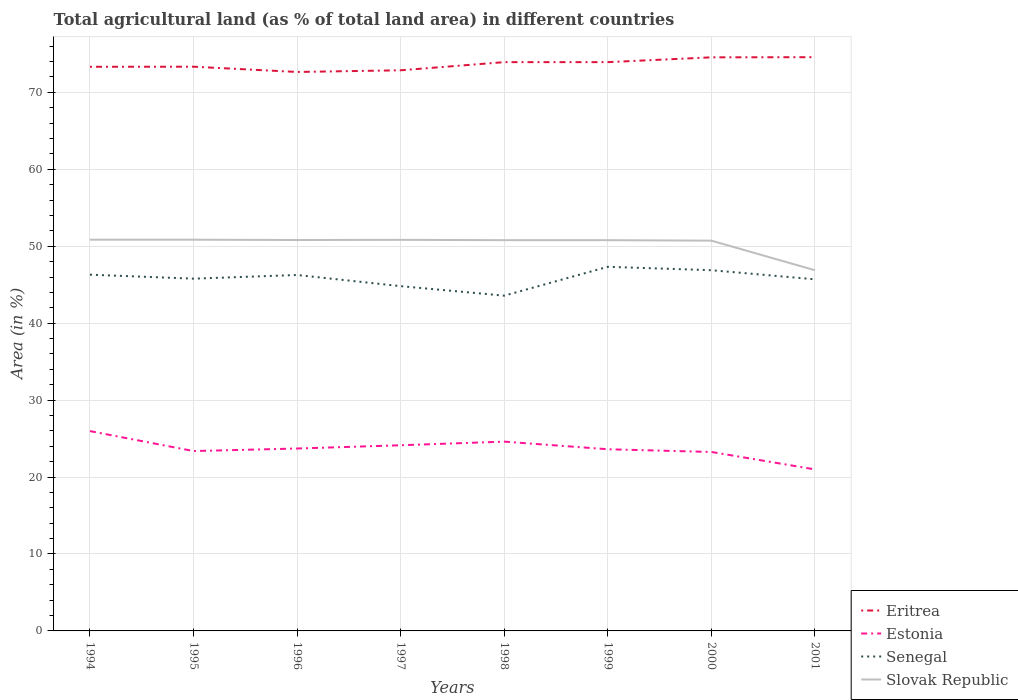How many different coloured lines are there?
Provide a short and direct response. 4. Does the line corresponding to Slovak Republic intersect with the line corresponding to Eritrea?
Keep it short and to the point. No. Across all years, what is the maximum percentage of agricultural land in Estonia?
Your response must be concise. 21. In which year was the percentage of agricultural land in Estonia maximum?
Offer a terse response. 2001. What is the total percentage of agricultural land in Eritrea in the graph?
Your response must be concise. -0.62. What is the difference between the highest and the second highest percentage of agricultural land in Senegal?
Keep it short and to the point. 3.75. Is the percentage of agricultural land in Eritrea strictly greater than the percentage of agricultural land in Senegal over the years?
Keep it short and to the point. No. How many lines are there?
Your answer should be compact. 4. How many years are there in the graph?
Provide a succinct answer. 8. Does the graph contain any zero values?
Provide a succinct answer. No. Does the graph contain grids?
Offer a terse response. Yes. Where does the legend appear in the graph?
Keep it short and to the point. Bottom right. How are the legend labels stacked?
Your response must be concise. Vertical. What is the title of the graph?
Ensure brevity in your answer.  Total agricultural land (as % of total land area) in different countries. What is the label or title of the X-axis?
Your answer should be very brief. Years. What is the label or title of the Y-axis?
Provide a short and direct response. Area (in %). What is the Area (in %) in Eritrea in 1994?
Keep it short and to the point. 73.33. What is the Area (in %) in Estonia in 1994?
Provide a succinct answer. 25.97. What is the Area (in %) of Senegal in 1994?
Offer a terse response. 46.3. What is the Area (in %) in Slovak Republic in 1994?
Provide a short and direct response. 50.85. What is the Area (in %) of Eritrea in 1995?
Keep it short and to the point. 73.34. What is the Area (in %) in Estonia in 1995?
Ensure brevity in your answer.  23.38. What is the Area (in %) in Senegal in 1995?
Offer a very short reply. 45.79. What is the Area (in %) of Slovak Republic in 1995?
Your answer should be compact. 50.85. What is the Area (in %) of Eritrea in 1996?
Ensure brevity in your answer.  72.65. What is the Area (in %) of Estonia in 1996?
Make the answer very short. 23.71. What is the Area (in %) in Senegal in 1996?
Your response must be concise. 46.26. What is the Area (in %) of Slovak Republic in 1996?
Provide a succinct answer. 50.81. What is the Area (in %) of Eritrea in 1997?
Make the answer very short. 72.87. What is the Area (in %) in Estonia in 1997?
Ensure brevity in your answer.  24.13. What is the Area (in %) of Senegal in 1997?
Offer a terse response. 44.81. What is the Area (in %) in Slovak Republic in 1997?
Your answer should be compact. 50.83. What is the Area (in %) of Eritrea in 1998?
Provide a succinct answer. 73.93. What is the Area (in %) of Estonia in 1998?
Your response must be concise. 24.6. What is the Area (in %) of Senegal in 1998?
Offer a terse response. 43.58. What is the Area (in %) in Slovak Republic in 1998?
Provide a short and direct response. 50.79. What is the Area (in %) in Eritrea in 1999?
Offer a very short reply. 73.93. What is the Area (in %) in Estonia in 1999?
Provide a succinct answer. 23.61. What is the Area (in %) of Senegal in 1999?
Provide a short and direct response. 47.33. What is the Area (in %) in Slovak Republic in 1999?
Offer a very short reply. 50.79. What is the Area (in %) of Eritrea in 2000?
Your answer should be very brief. 74.55. What is the Area (in %) in Estonia in 2000?
Your answer should be compact. 23.26. What is the Area (in %) of Senegal in 2000?
Give a very brief answer. 46.89. What is the Area (in %) in Slovak Republic in 2000?
Your response must be concise. 50.73. What is the Area (in %) in Eritrea in 2001?
Your answer should be compact. 74.57. What is the Area (in %) of Estonia in 2001?
Your response must be concise. 21. What is the Area (in %) of Senegal in 2001?
Your answer should be very brief. 45.7. What is the Area (in %) in Slovak Republic in 2001?
Offer a terse response. 46.88. Across all years, what is the maximum Area (in %) of Eritrea?
Offer a terse response. 74.57. Across all years, what is the maximum Area (in %) in Estonia?
Your response must be concise. 25.97. Across all years, what is the maximum Area (in %) of Senegal?
Make the answer very short. 47.33. Across all years, what is the maximum Area (in %) of Slovak Republic?
Offer a terse response. 50.85. Across all years, what is the minimum Area (in %) of Eritrea?
Your response must be concise. 72.65. Across all years, what is the minimum Area (in %) of Estonia?
Your answer should be compact. 21. Across all years, what is the minimum Area (in %) in Senegal?
Your answer should be compact. 43.58. Across all years, what is the minimum Area (in %) in Slovak Republic?
Provide a succinct answer. 46.88. What is the total Area (in %) in Eritrea in the graph?
Your response must be concise. 589.18. What is the total Area (in %) in Estonia in the graph?
Keep it short and to the point. 189.67. What is the total Area (in %) in Senegal in the graph?
Your response must be concise. 366.66. What is the total Area (in %) of Slovak Republic in the graph?
Offer a terse response. 402.54. What is the difference between the Area (in %) of Eritrea in 1994 and that in 1995?
Provide a short and direct response. -0.01. What is the difference between the Area (in %) in Estonia in 1994 and that in 1995?
Provide a short and direct response. 2.6. What is the difference between the Area (in %) of Senegal in 1994 and that in 1995?
Make the answer very short. 0.52. What is the difference between the Area (in %) in Eritrea in 1994 and that in 1996?
Provide a succinct answer. 0.67. What is the difference between the Area (in %) in Estonia in 1994 and that in 1996?
Your response must be concise. 2.26. What is the difference between the Area (in %) in Senegal in 1994 and that in 1996?
Offer a very short reply. 0.04. What is the difference between the Area (in %) in Slovak Republic in 1994 and that in 1996?
Make the answer very short. 0.04. What is the difference between the Area (in %) of Eritrea in 1994 and that in 1997?
Make the answer very short. 0.46. What is the difference between the Area (in %) in Estonia in 1994 and that in 1997?
Keep it short and to the point. 1.84. What is the difference between the Area (in %) of Senegal in 1994 and that in 1997?
Make the answer very short. 1.49. What is the difference between the Area (in %) in Slovak Republic in 1994 and that in 1997?
Ensure brevity in your answer.  0.02. What is the difference between the Area (in %) of Eritrea in 1994 and that in 1998?
Ensure brevity in your answer.  -0.6. What is the difference between the Area (in %) of Estonia in 1994 and that in 1998?
Provide a succinct answer. 1.37. What is the difference between the Area (in %) in Senegal in 1994 and that in 1998?
Make the answer very short. 2.73. What is the difference between the Area (in %) in Slovak Republic in 1994 and that in 1998?
Your answer should be compact. 0.06. What is the difference between the Area (in %) in Eritrea in 1994 and that in 1999?
Your answer should be compact. -0.6. What is the difference between the Area (in %) in Estonia in 1994 and that in 1999?
Your answer should be very brief. 2.36. What is the difference between the Area (in %) in Senegal in 1994 and that in 1999?
Your answer should be very brief. -1.02. What is the difference between the Area (in %) in Slovak Republic in 1994 and that in 1999?
Your answer should be very brief. 0.06. What is the difference between the Area (in %) in Eritrea in 1994 and that in 2000?
Give a very brief answer. -1.23. What is the difference between the Area (in %) in Estonia in 1994 and that in 2000?
Your answer should be compact. 2.71. What is the difference between the Area (in %) in Senegal in 1994 and that in 2000?
Make the answer very short. -0.58. What is the difference between the Area (in %) in Slovak Republic in 1994 and that in 2000?
Your answer should be very brief. 0.12. What is the difference between the Area (in %) of Eritrea in 1994 and that in 2001?
Provide a succinct answer. -1.25. What is the difference between the Area (in %) in Estonia in 1994 and that in 2001?
Offer a terse response. 4.98. What is the difference between the Area (in %) of Senegal in 1994 and that in 2001?
Your answer should be compact. 0.6. What is the difference between the Area (in %) of Slovak Republic in 1994 and that in 2001?
Provide a short and direct response. 3.97. What is the difference between the Area (in %) in Eritrea in 1995 and that in 1996?
Make the answer very short. 0.68. What is the difference between the Area (in %) in Estonia in 1995 and that in 1996?
Ensure brevity in your answer.  -0.33. What is the difference between the Area (in %) of Senegal in 1995 and that in 1996?
Provide a succinct answer. -0.48. What is the difference between the Area (in %) in Slovak Republic in 1995 and that in 1996?
Provide a succinct answer. 0.04. What is the difference between the Area (in %) of Eritrea in 1995 and that in 1997?
Your answer should be compact. 0.47. What is the difference between the Area (in %) of Estonia in 1995 and that in 1997?
Offer a terse response. -0.75. What is the difference between the Area (in %) in Senegal in 1995 and that in 1997?
Your answer should be very brief. 0.97. What is the difference between the Area (in %) of Slovak Republic in 1995 and that in 1997?
Your answer should be very brief. 0.02. What is the difference between the Area (in %) of Eritrea in 1995 and that in 1998?
Make the answer very short. -0.59. What is the difference between the Area (in %) in Estonia in 1995 and that in 1998?
Offer a very short reply. -1.23. What is the difference between the Area (in %) of Senegal in 1995 and that in 1998?
Your response must be concise. 2.21. What is the difference between the Area (in %) in Slovak Republic in 1995 and that in 1998?
Your answer should be compact. 0.06. What is the difference between the Area (in %) of Eritrea in 1995 and that in 1999?
Provide a short and direct response. -0.59. What is the difference between the Area (in %) in Estonia in 1995 and that in 1999?
Give a very brief answer. -0.24. What is the difference between the Area (in %) of Senegal in 1995 and that in 1999?
Offer a terse response. -1.54. What is the difference between the Area (in %) of Slovak Republic in 1995 and that in 1999?
Make the answer very short. 0.06. What is the difference between the Area (in %) of Eritrea in 1995 and that in 2000?
Your response must be concise. -1.22. What is the difference between the Area (in %) in Estonia in 1995 and that in 2000?
Your answer should be very brief. 0.12. What is the difference between the Area (in %) in Senegal in 1995 and that in 2000?
Your answer should be very brief. -1.1. What is the difference between the Area (in %) of Slovak Republic in 1995 and that in 2000?
Ensure brevity in your answer.  0.12. What is the difference between the Area (in %) in Eritrea in 1995 and that in 2001?
Offer a terse response. -1.24. What is the difference between the Area (in %) of Estonia in 1995 and that in 2001?
Your response must be concise. 2.38. What is the difference between the Area (in %) in Senegal in 1995 and that in 2001?
Your answer should be very brief. 0.08. What is the difference between the Area (in %) in Slovak Republic in 1995 and that in 2001?
Give a very brief answer. 3.97. What is the difference between the Area (in %) of Eritrea in 1996 and that in 1997?
Offer a very short reply. -0.22. What is the difference between the Area (in %) of Estonia in 1996 and that in 1997?
Provide a short and direct response. -0.42. What is the difference between the Area (in %) of Senegal in 1996 and that in 1997?
Keep it short and to the point. 1.45. What is the difference between the Area (in %) of Slovak Republic in 1996 and that in 1997?
Provide a succinct answer. -0.02. What is the difference between the Area (in %) in Eritrea in 1996 and that in 1998?
Give a very brief answer. -1.28. What is the difference between the Area (in %) in Estonia in 1996 and that in 1998?
Offer a terse response. -0.9. What is the difference between the Area (in %) of Senegal in 1996 and that in 1998?
Ensure brevity in your answer.  2.69. What is the difference between the Area (in %) in Slovak Republic in 1996 and that in 1998?
Ensure brevity in your answer.  0.02. What is the difference between the Area (in %) of Eritrea in 1996 and that in 1999?
Your answer should be compact. -1.28. What is the difference between the Area (in %) of Estonia in 1996 and that in 1999?
Provide a succinct answer. 0.09. What is the difference between the Area (in %) of Senegal in 1996 and that in 1999?
Keep it short and to the point. -1.06. What is the difference between the Area (in %) of Slovak Republic in 1996 and that in 1999?
Your response must be concise. 0.02. What is the difference between the Area (in %) in Eritrea in 1996 and that in 2000?
Your answer should be very brief. -1.9. What is the difference between the Area (in %) of Estonia in 1996 and that in 2000?
Give a very brief answer. 0.45. What is the difference between the Area (in %) of Senegal in 1996 and that in 2000?
Provide a succinct answer. -0.62. What is the difference between the Area (in %) in Slovak Republic in 1996 and that in 2000?
Your response must be concise. 0.08. What is the difference between the Area (in %) of Eritrea in 1996 and that in 2001?
Provide a short and direct response. -1.92. What is the difference between the Area (in %) of Estonia in 1996 and that in 2001?
Your answer should be compact. 2.71. What is the difference between the Area (in %) in Senegal in 1996 and that in 2001?
Offer a very short reply. 0.56. What is the difference between the Area (in %) of Slovak Republic in 1996 and that in 2001?
Your answer should be compact. 3.93. What is the difference between the Area (in %) in Eritrea in 1997 and that in 1998?
Ensure brevity in your answer.  -1.06. What is the difference between the Area (in %) of Estonia in 1997 and that in 1998?
Ensure brevity in your answer.  -0.47. What is the difference between the Area (in %) in Senegal in 1997 and that in 1998?
Your response must be concise. 1.24. What is the difference between the Area (in %) of Slovak Republic in 1997 and that in 1998?
Ensure brevity in your answer.  0.04. What is the difference between the Area (in %) in Eritrea in 1997 and that in 1999?
Your answer should be very brief. -1.06. What is the difference between the Area (in %) of Estonia in 1997 and that in 1999?
Provide a succinct answer. 0.52. What is the difference between the Area (in %) in Senegal in 1997 and that in 1999?
Keep it short and to the point. -2.51. What is the difference between the Area (in %) in Slovak Republic in 1997 and that in 1999?
Offer a very short reply. 0.04. What is the difference between the Area (in %) in Eritrea in 1997 and that in 2000?
Offer a terse response. -1.68. What is the difference between the Area (in %) in Estonia in 1997 and that in 2000?
Give a very brief answer. 0.87. What is the difference between the Area (in %) of Senegal in 1997 and that in 2000?
Your response must be concise. -2.07. What is the difference between the Area (in %) of Slovak Republic in 1997 and that in 2000?
Your response must be concise. 0.1. What is the difference between the Area (in %) in Eritrea in 1997 and that in 2001?
Your response must be concise. -1.7. What is the difference between the Area (in %) in Estonia in 1997 and that in 2001?
Give a very brief answer. 3.14. What is the difference between the Area (in %) in Senegal in 1997 and that in 2001?
Make the answer very short. -0.89. What is the difference between the Area (in %) in Slovak Republic in 1997 and that in 2001?
Make the answer very short. 3.95. What is the difference between the Area (in %) of Senegal in 1998 and that in 1999?
Your answer should be very brief. -3.75. What is the difference between the Area (in %) of Eritrea in 1998 and that in 2000?
Give a very brief answer. -0.62. What is the difference between the Area (in %) of Estonia in 1998 and that in 2000?
Keep it short and to the point. 1.34. What is the difference between the Area (in %) of Senegal in 1998 and that in 2000?
Provide a short and direct response. -3.31. What is the difference between the Area (in %) of Slovak Republic in 1998 and that in 2000?
Give a very brief answer. 0.06. What is the difference between the Area (in %) in Eritrea in 1998 and that in 2001?
Offer a terse response. -0.64. What is the difference between the Area (in %) of Estonia in 1998 and that in 2001?
Keep it short and to the point. 3.61. What is the difference between the Area (in %) of Senegal in 1998 and that in 2001?
Your answer should be compact. -2.12. What is the difference between the Area (in %) of Slovak Republic in 1998 and that in 2001?
Your answer should be compact. 3.91. What is the difference between the Area (in %) of Eritrea in 1999 and that in 2000?
Keep it short and to the point. -0.62. What is the difference between the Area (in %) in Estonia in 1999 and that in 2000?
Provide a short and direct response. 0.35. What is the difference between the Area (in %) in Senegal in 1999 and that in 2000?
Your answer should be compact. 0.44. What is the difference between the Area (in %) in Slovak Republic in 1999 and that in 2000?
Keep it short and to the point. 0.06. What is the difference between the Area (in %) of Eritrea in 1999 and that in 2001?
Offer a very short reply. -0.64. What is the difference between the Area (in %) of Estonia in 1999 and that in 2001?
Your answer should be compact. 2.62. What is the difference between the Area (in %) in Senegal in 1999 and that in 2001?
Your answer should be very brief. 1.63. What is the difference between the Area (in %) of Slovak Republic in 1999 and that in 2001?
Provide a succinct answer. 3.91. What is the difference between the Area (in %) in Eritrea in 2000 and that in 2001?
Provide a succinct answer. -0.02. What is the difference between the Area (in %) of Estonia in 2000 and that in 2001?
Keep it short and to the point. 2.26. What is the difference between the Area (in %) of Senegal in 2000 and that in 2001?
Your answer should be compact. 1.18. What is the difference between the Area (in %) of Slovak Republic in 2000 and that in 2001?
Ensure brevity in your answer.  3.85. What is the difference between the Area (in %) in Eritrea in 1994 and the Area (in %) in Estonia in 1995?
Your answer should be very brief. 49.95. What is the difference between the Area (in %) in Eritrea in 1994 and the Area (in %) in Senegal in 1995?
Ensure brevity in your answer.  27.54. What is the difference between the Area (in %) in Eritrea in 1994 and the Area (in %) in Slovak Republic in 1995?
Offer a very short reply. 22.47. What is the difference between the Area (in %) in Estonia in 1994 and the Area (in %) in Senegal in 1995?
Your answer should be very brief. -19.81. What is the difference between the Area (in %) of Estonia in 1994 and the Area (in %) of Slovak Republic in 1995?
Offer a terse response. -24.88. What is the difference between the Area (in %) in Senegal in 1994 and the Area (in %) in Slovak Republic in 1995?
Make the answer very short. -4.55. What is the difference between the Area (in %) of Eritrea in 1994 and the Area (in %) of Estonia in 1996?
Make the answer very short. 49.62. What is the difference between the Area (in %) in Eritrea in 1994 and the Area (in %) in Senegal in 1996?
Provide a short and direct response. 27.06. What is the difference between the Area (in %) of Eritrea in 1994 and the Area (in %) of Slovak Republic in 1996?
Your response must be concise. 22.52. What is the difference between the Area (in %) of Estonia in 1994 and the Area (in %) of Senegal in 1996?
Ensure brevity in your answer.  -20.29. What is the difference between the Area (in %) of Estonia in 1994 and the Area (in %) of Slovak Republic in 1996?
Keep it short and to the point. -24.84. What is the difference between the Area (in %) of Senegal in 1994 and the Area (in %) of Slovak Republic in 1996?
Keep it short and to the point. -4.51. What is the difference between the Area (in %) of Eritrea in 1994 and the Area (in %) of Estonia in 1997?
Ensure brevity in your answer.  49.19. What is the difference between the Area (in %) in Eritrea in 1994 and the Area (in %) in Senegal in 1997?
Ensure brevity in your answer.  28.51. What is the difference between the Area (in %) in Eritrea in 1994 and the Area (in %) in Slovak Republic in 1997?
Keep it short and to the point. 22.5. What is the difference between the Area (in %) in Estonia in 1994 and the Area (in %) in Senegal in 1997?
Provide a short and direct response. -18.84. What is the difference between the Area (in %) in Estonia in 1994 and the Area (in %) in Slovak Republic in 1997?
Your response must be concise. -24.86. What is the difference between the Area (in %) of Senegal in 1994 and the Area (in %) of Slovak Republic in 1997?
Keep it short and to the point. -4.53. What is the difference between the Area (in %) in Eritrea in 1994 and the Area (in %) in Estonia in 1998?
Your answer should be very brief. 48.72. What is the difference between the Area (in %) in Eritrea in 1994 and the Area (in %) in Senegal in 1998?
Make the answer very short. 29.75. What is the difference between the Area (in %) of Eritrea in 1994 and the Area (in %) of Slovak Republic in 1998?
Provide a short and direct response. 22.54. What is the difference between the Area (in %) of Estonia in 1994 and the Area (in %) of Senegal in 1998?
Keep it short and to the point. -17.6. What is the difference between the Area (in %) in Estonia in 1994 and the Area (in %) in Slovak Republic in 1998?
Your answer should be very brief. -24.82. What is the difference between the Area (in %) of Senegal in 1994 and the Area (in %) of Slovak Republic in 1998?
Make the answer very short. -4.49. What is the difference between the Area (in %) in Eritrea in 1994 and the Area (in %) in Estonia in 1999?
Your answer should be very brief. 49.71. What is the difference between the Area (in %) of Eritrea in 1994 and the Area (in %) of Senegal in 1999?
Keep it short and to the point. 26. What is the difference between the Area (in %) in Eritrea in 1994 and the Area (in %) in Slovak Republic in 1999?
Provide a succinct answer. 22.54. What is the difference between the Area (in %) in Estonia in 1994 and the Area (in %) in Senegal in 1999?
Provide a short and direct response. -21.35. What is the difference between the Area (in %) of Estonia in 1994 and the Area (in %) of Slovak Republic in 1999?
Your answer should be compact. -24.82. What is the difference between the Area (in %) in Senegal in 1994 and the Area (in %) in Slovak Republic in 1999?
Provide a succinct answer. -4.49. What is the difference between the Area (in %) of Eritrea in 1994 and the Area (in %) of Estonia in 2000?
Keep it short and to the point. 50.07. What is the difference between the Area (in %) of Eritrea in 1994 and the Area (in %) of Senegal in 2000?
Make the answer very short. 26.44. What is the difference between the Area (in %) in Eritrea in 1994 and the Area (in %) in Slovak Republic in 2000?
Provide a succinct answer. 22.6. What is the difference between the Area (in %) of Estonia in 1994 and the Area (in %) of Senegal in 2000?
Keep it short and to the point. -20.91. What is the difference between the Area (in %) of Estonia in 1994 and the Area (in %) of Slovak Republic in 2000?
Provide a short and direct response. -24.75. What is the difference between the Area (in %) of Senegal in 1994 and the Area (in %) of Slovak Republic in 2000?
Offer a terse response. -4.42. What is the difference between the Area (in %) in Eritrea in 1994 and the Area (in %) in Estonia in 2001?
Your answer should be very brief. 52.33. What is the difference between the Area (in %) of Eritrea in 1994 and the Area (in %) of Senegal in 2001?
Provide a succinct answer. 27.62. What is the difference between the Area (in %) of Eritrea in 1994 and the Area (in %) of Slovak Republic in 2001?
Provide a short and direct response. 26.45. What is the difference between the Area (in %) of Estonia in 1994 and the Area (in %) of Senegal in 2001?
Offer a very short reply. -19.73. What is the difference between the Area (in %) in Estonia in 1994 and the Area (in %) in Slovak Republic in 2001?
Make the answer very short. -20.91. What is the difference between the Area (in %) in Senegal in 1994 and the Area (in %) in Slovak Republic in 2001?
Offer a terse response. -0.58. What is the difference between the Area (in %) of Eritrea in 1995 and the Area (in %) of Estonia in 1996?
Your answer should be very brief. 49.63. What is the difference between the Area (in %) of Eritrea in 1995 and the Area (in %) of Senegal in 1996?
Your response must be concise. 27.07. What is the difference between the Area (in %) in Eritrea in 1995 and the Area (in %) in Slovak Republic in 1996?
Your response must be concise. 22.53. What is the difference between the Area (in %) of Estonia in 1995 and the Area (in %) of Senegal in 1996?
Give a very brief answer. -22.88. What is the difference between the Area (in %) in Estonia in 1995 and the Area (in %) in Slovak Republic in 1996?
Offer a terse response. -27.43. What is the difference between the Area (in %) in Senegal in 1995 and the Area (in %) in Slovak Republic in 1996?
Offer a terse response. -5.03. What is the difference between the Area (in %) of Eritrea in 1995 and the Area (in %) of Estonia in 1997?
Give a very brief answer. 49.2. What is the difference between the Area (in %) in Eritrea in 1995 and the Area (in %) in Senegal in 1997?
Give a very brief answer. 28.52. What is the difference between the Area (in %) in Eritrea in 1995 and the Area (in %) in Slovak Republic in 1997?
Your answer should be compact. 22.5. What is the difference between the Area (in %) in Estonia in 1995 and the Area (in %) in Senegal in 1997?
Make the answer very short. -21.44. What is the difference between the Area (in %) of Estonia in 1995 and the Area (in %) of Slovak Republic in 1997?
Ensure brevity in your answer.  -27.45. What is the difference between the Area (in %) in Senegal in 1995 and the Area (in %) in Slovak Republic in 1997?
Provide a short and direct response. -5.05. What is the difference between the Area (in %) in Eritrea in 1995 and the Area (in %) in Estonia in 1998?
Make the answer very short. 48.73. What is the difference between the Area (in %) of Eritrea in 1995 and the Area (in %) of Senegal in 1998?
Give a very brief answer. 29.76. What is the difference between the Area (in %) of Eritrea in 1995 and the Area (in %) of Slovak Republic in 1998?
Offer a very short reply. 22.55. What is the difference between the Area (in %) in Estonia in 1995 and the Area (in %) in Senegal in 1998?
Provide a short and direct response. -20.2. What is the difference between the Area (in %) of Estonia in 1995 and the Area (in %) of Slovak Republic in 1998?
Provide a succinct answer. -27.41. What is the difference between the Area (in %) of Senegal in 1995 and the Area (in %) of Slovak Republic in 1998?
Your answer should be very brief. -5. What is the difference between the Area (in %) in Eritrea in 1995 and the Area (in %) in Estonia in 1999?
Make the answer very short. 49.72. What is the difference between the Area (in %) in Eritrea in 1995 and the Area (in %) in Senegal in 1999?
Offer a very short reply. 26.01. What is the difference between the Area (in %) in Eritrea in 1995 and the Area (in %) in Slovak Republic in 1999?
Give a very brief answer. 22.55. What is the difference between the Area (in %) in Estonia in 1995 and the Area (in %) in Senegal in 1999?
Offer a very short reply. -23.95. What is the difference between the Area (in %) of Estonia in 1995 and the Area (in %) of Slovak Republic in 1999?
Your answer should be very brief. -27.41. What is the difference between the Area (in %) of Senegal in 1995 and the Area (in %) of Slovak Republic in 1999?
Offer a terse response. -5. What is the difference between the Area (in %) in Eritrea in 1995 and the Area (in %) in Estonia in 2000?
Your answer should be compact. 50.08. What is the difference between the Area (in %) of Eritrea in 1995 and the Area (in %) of Senegal in 2000?
Your answer should be very brief. 26.45. What is the difference between the Area (in %) of Eritrea in 1995 and the Area (in %) of Slovak Republic in 2000?
Your answer should be compact. 22.61. What is the difference between the Area (in %) of Estonia in 1995 and the Area (in %) of Senegal in 2000?
Offer a terse response. -23.51. What is the difference between the Area (in %) in Estonia in 1995 and the Area (in %) in Slovak Republic in 2000?
Provide a succinct answer. -27.35. What is the difference between the Area (in %) in Senegal in 1995 and the Area (in %) in Slovak Republic in 2000?
Give a very brief answer. -4.94. What is the difference between the Area (in %) of Eritrea in 1995 and the Area (in %) of Estonia in 2001?
Offer a terse response. 52.34. What is the difference between the Area (in %) of Eritrea in 1995 and the Area (in %) of Senegal in 2001?
Make the answer very short. 27.63. What is the difference between the Area (in %) in Eritrea in 1995 and the Area (in %) in Slovak Republic in 2001?
Give a very brief answer. 26.46. What is the difference between the Area (in %) in Estonia in 1995 and the Area (in %) in Senegal in 2001?
Offer a terse response. -22.32. What is the difference between the Area (in %) in Estonia in 1995 and the Area (in %) in Slovak Republic in 2001?
Ensure brevity in your answer.  -23.5. What is the difference between the Area (in %) in Senegal in 1995 and the Area (in %) in Slovak Republic in 2001?
Provide a succinct answer. -1.1. What is the difference between the Area (in %) of Eritrea in 1996 and the Area (in %) of Estonia in 1997?
Offer a terse response. 48.52. What is the difference between the Area (in %) of Eritrea in 1996 and the Area (in %) of Senegal in 1997?
Make the answer very short. 27.84. What is the difference between the Area (in %) of Eritrea in 1996 and the Area (in %) of Slovak Republic in 1997?
Give a very brief answer. 21.82. What is the difference between the Area (in %) of Estonia in 1996 and the Area (in %) of Senegal in 1997?
Offer a very short reply. -21.11. What is the difference between the Area (in %) in Estonia in 1996 and the Area (in %) in Slovak Republic in 1997?
Ensure brevity in your answer.  -27.12. What is the difference between the Area (in %) of Senegal in 1996 and the Area (in %) of Slovak Republic in 1997?
Keep it short and to the point. -4.57. What is the difference between the Area (in %) of Eritrea in 1996 and the Area (in %) of Estonia in 1998?
Keep it short and to the point. 48.05. What is the difference between the Area (in %) of Eritrea in 1996 and the Area (in %) of Senegal in 1998?
Your answer should be compact. 29.08. What is the difference between the Area (in %) in Eritrea in 1996 and the Area (in %) in Slovak Republic in 1998?
Ensure brevity in your answer.  21.86. What is the difference between the Area (in %) in Estonia in 1996 and the Area (in %) in Senegal in 1998?
Offer a terse response. -19.87. What is the difference between the Area (in %) in Estonia in 1996 and the Area (in %) in Slovak Republic in 1998?
Your response must be concise. -27.08. What is the difference between the Area (in %) in Senegal in 1996 and the Area (in %) in Slovak Republic in 1998?
Ensure brevity in your answer.  -4.53. What is the difference between the Area (in %) of Eritrea in 1996 and the Area (in %) of Estonia in 1999?
Your answer should be very brief. 49.04. What is the difference between the Area (in %) of Eritrea in 1996 and the Area (in %) of Senegal in 1999?
Offer a terse response. 25.33. What is the difference between the Area (in %) of Eritrea in 1996 and the Area (in %) of Slovak Republic in 1999?
Make the answer very short. 21.86. What is the difference between the Area (in %) in Estonia in 1996 and the Area (in %) in Senegal in 1999?
Give a very brief answer. -23.62. What is the difference between the Area (in %) in Estonia in 1996 and the Area (in %) in Slovak Republic in 1999?
Provide a succinct answer. -27.08. What is the difference between the Area (in %) in Senegal in 1996 and the Area (in %) in Slovak Republic in 1999?
Your response must be concise. -4.53. What is the difference between the Area (in %) in Eritrea in 1996 and the Area (in %) in Estonia in 2000?
Make the answer very short. 49.39. What is the difference between the Area (in %) of Eritrea in 1996 and the Area (in %) of Senegal in 2000?
Your response must be concise. 25.77. What is the difference between the Area (in %) of Eritrea in 1996 and the Area (in %) of Slovak Republic in 2000?
Your answer should be very brief. 21.93. What is the difference between the Area (in %) in Estonia in 1996 and the Area (in %) in Senegal in 2000?
Make the answer very short. -23.18. What is the difference between the Area (in %) in Estonia in 1996 and the Area (in %) in Slovak Republic in 2000?
Provide a succinct answer. -27.02. What is the difference between the Area (in %) in Senegal in 1996 and the Area (in %) in Slovak Republic in 2000?
Offer a terse response. -4.46. What is the difference between the Area (in %) in Eritrea in 1996 and the Area (in %) in Estonia in 2001?
Your response must be concise. 51.66. What is the difference between the Area (in %) in Eritrea in 1996 and the Area (in %) in Senegal in 2001?
Offer a terse response. 26.95. What is the difference between the Area (in %) of Eritrea in 1996 and the Area (in %) of Slovak Republic in 2001?
Offer a terse response. 25.77. What is the difference between the Area (in %) of Estonia in 1996 and the Area (in %) of Senegal in 2001?
Offer a very short reply. -21.99. What is the difference between the Area (in %) of Estonia in 1996 and the Area (in %) of Slovak Republic in 2001?
Ensure brevity in your answer.  -23.17. What is the difference between the Area (in %) in Senegal in 1996 and the Area (in %) in Slovak Republic in 2001?
Offer a terse response. -0.62. What is the difference between the Area (in %) of Eritrea in 1997 and the Area (in %) of Estonia in 1998?
Provide a short and direct response. 48.27. What is the difference between the Area (in %) in Eritrea in 1997 and the Area (in %) in Senegal in 1998?
Make the answer very short. 29.29. What is the difference between the Area (in %) of Eritrea in 1997 and the Area (in %) of Slovak Republic in 1998?
Give a very brief answer. 22.08. What is the difference between the Area (in %) in Estonia in 1997 and the Area (in %) in Senegal in 1998?
Give a very brief answer. -19.44. What is the difference between the Area (in %) in Estonia in 1997 and the Area (in %) in Slovak Republic in 1998?
Ensure brevity in your answer.  -26.66. What is the difference between the Area (in %) in Senegal in 1997 and the Area (in %) in Slovak Republic in 1998?
Provide a short and direct response. -5.98. What is the difference between the Area (in %) of Eritrea in 1997 and the Area (in %) of Estonia in 1999?
Provide a succinct answer. 49.26. What is the difference between the Area (in %) in Eritrea in 1997 and the Area (in %) in Senegal in 1999?
Make the answer very short. 25.54. What is the difference between the Area (in %) of Eritrea in 1997 and the Area (in %) of Slovak Republic in 1999?
Make the answer very short. 22.08. What is the difference between the Area (in %) of Estonia in 1997 and the Area (in %) of Senegal in 1999?
Offer a very short reply. -23.19. What is the difference between the Area (in %) of Estonia in 1997 and the Area (in %) of Slovak Republic in 1999?
Keep it short and to the point. -26.66. What is the difference between the Area (in %) in Senegal in 1997 and the Area (in %) in Slovak Republic in 1999?
Provide a short and direct response. -5.98. What is the difference between the Area (in %) of Eritrea in 1997 and the Area (in %) of Estonia in 2000?
Your answer should be compact. 49.61. What is the difference between the Area (in %) in Eritrea in 1997 and the Area (in %) in Senegal in 2000?
Provide a succinct answer. 25.99. What is the difference between the Area (in %) of Eritrea in 1997 and the Area (in %) of Slovak Republic in 2000?
Offer a terse response. 22.14. What is the difference between the Area (in %) of Estonia in 1997 and the Area (in %) of Senegal in 2000?
Your response must be concise. -22.75. What is the difference between the Area (in %) in Estonia in 1997 and the Area (in %) in Slovak Republic in 2000?
Give a very brief answer. -26.59. What is the difference between the Area (in %) of Senegal in 1997 and the Area (in %) of Slovak Republic in 2000?
Give a very brief answer. -5.91. What is the difference between the Area (in %) in Eritrea in 1997 and the Area (in %) in Estonia in 2001?
Ensure brevity in your answer.  51.88. What is the difference between the Area (in %) of Eritrea in 1997 and the Area (in %) of Senegal in 2001?
Your response must be concise. 27.17. What is the difference between the Area (in %) in Eritrea in 1997 and the Area (in %) in Slovak Republic in 2001?
Offer a very short reply. 25.99. What is the difference between the Area (in %) in Estonia in 1997 and the Area (in %) in Senegal in 2001?
Your answer should be compact. -21.57. What is the difference between the Area (in %) of Estonia in 1997 and the Area (in %) of Slovak Republic in 2001?
Provide a succinct answer. -22.75. What is the difference between the Area (in %) in Senegal in 1997 and the Area (in %) in Slovak Republic in 2001?
Keep it short and to the point. -2.07. What is the difference between the Area (in %) of Eritrea in 1998 and the Area (in %) of Estonia in 1999?
Your answer should be very brief. 50.32. What is the difference between the Area (in %) of Eritrea in 1998 and the Area (in %) of Senegal in 1999?
Offer a terse response. 26.6. What is the difference between the Area (in %) of Eritrea in 1998 and the Area (in %) of Slovak Republic in 1999?
Give a very brief answer. 23.14. What is the difference between the Area (in %) of Estonia in 1998 and the Area (in %) of Senegal in 1999?
Keep it short and to the point. -22.72. What is the difference between the Area (in %) in Estonia in 1998 and the Area (in %) in Slovak Republic in 1999?
Ensure brevity in your answer.  -26.19. What is the difference between the Area (in %) in Senegal in 1998 and the Area (in %) in Slovak Republic in 1999?
Offer a terse response. -7.21. What is the difference between the Area (in %) of Eritrea in 1998 and the Area (in %) of Estonia in 2000?
Ensure brevity in your answer.  50.67. What is the difference between the Area (in %) of Eritrea in 1998 and the Area (in %) of Senegal in 2000?
Ensure brevity in your answer.  27.04. What is the difference between the Area (in %) of Eritrea in 1998 and the Area (in %) of Slovak Republic in 2000?
Your answer should be very brief. 23.2. What is the difference between the Area (in %) in Estonia in 1998 and the Area (in %) in Senegal in 2000?
Ensure brevity in your answer.  -22.28. What is the difference between the Area (in %) of Estonia in 1998 and the Area (in %) of Slovak Republic in 2000?
Ensure brevity in your answer.  -26.12. What is the difference between the Area (in %) of Senegal in 1998 and the Area (in %) of Slovak Republic in 2000?
Your response must be concise. -7.15. What is the difference between the Area (in %) of Eritrea in 1998 and the Area (in %) of Estonia in 2001?
Ensure brevity in your answer.  52.94. What is the difference between the Area (in %) of Eritrea in 1998 and the Area (in %) of Senegal in 2001?
Ensure brevity in your answer.  28.23. What is the difference between the Area (in %) in Eritrea in 1998 and the Area (in %) in Slovak Republic in 2001?
Give a very brief answer. 27.05. What is the difference between the Area (in %) in Estonia in 1998 and the Area (in %) in Senegal in 2001?
Give a very brief answer. -21.1. What is the difference between the Area (in %) in Estonia in 1998 and the Area (in %) in Slovak Republic in 2001?
Give a very brief answer. -22.28. What is the difference between the Area (in %) of Senegal in 1998 and the Area (in %) of Slovak Republic in 2001?
Your answer should be very brief. -3.3. What is the difference between the Area (in %) in Eritrea in 1999 and the Area (in %) in Estonia in 2000?
Provide a short and direct response. 50.67. What is the difference between the Area (in %) of Eritrea in 1999 and the Area (in %) of Senegal in 2000?
Make the answer very short. 27.04. What is the difference between the Area (in %) in Eritrea in 1999 and the Area (in %) in Slovak Republic in 2000?
Offer a very short reply. 23.2. What is the difference between the Area (in %) in Estonia in 1999 and the Area (in %) in Senegal in 2000?
Your answer should be very brief. -23.27. What is the difference between the Area (in %) of Estonia in 1999 and the Area (in %) of Slovak Republic in 2000?
Ensure brevity in your answer.  -27.11. What is the difference between the Area (in %) of Senegal in 1999 and the Area (in %) of Slovak Republic in 2000?
Provide a short and direct response. -3.4. What is the difference between the Area (in %) in Eritrea in 1999 and the Area (in %) in Estonia in 2001?
Ensure brevity in your answer.  52.94. What is the difference between the Area (in %) in Eritrea in 1999 and the Area (in %) in Senegal in 2001?
Your response must be concise. 28.23. What is the difference between the Area (in %) of Eritrea in 1999 and the Area (in %) of Slovak Republic in 2001?
Keep it short and to the point. 27.05. What is the difference between the Area (in %) in Estonia in 1999 and the Area (in %) in Senegal in 2001?
Your answer should be very brief. -22.09. What is the difference between the Area (in %) in Estonia in 1999 and the Area (in %) in Slovak Republic in 2001?
Ensure brevity in your answer.  -23.27. What is the difference between the Area (in %) of Senegal in 1999 and the Area (in %) of Slovak Republic in 2001?
Provide a short and direct response. 0.45. What is the difference between the Area (in %) of Eritrea in 2000 and the Area (in %) of Estonia in 2001?
Ensure brevity in your answer.  53.56. What is the difference between the Area (in %) in Eritrea in 2000 and the Area (in %) in Senegal in 2001?
Your response must be concise. 28.85. What is the difference between the Area (in %) of Eritrea in 2000 and the Area (in %) of Slovak Republic in 2001?
Ensure brevity in your answer.  27.67. What is the difference between the Area (in %) of Estonia in 2000 and the Area (in %) of Senegal in 2001?
Offer a terse response. -22.44. What is the difference between the Area (in %) of Estonia in 2000 and the Area (in %) of Slovak Republic in 2001?
Keep it short and to the point. -23.62. What is the difference between the Area (in %) of Senegal in 2000 and the Area (in %) of Slovak Republic in 2001?
Provide a succinct answer. 0. What is the average Area (in %) in Eritrea per year?
Offer a terse response. 73.65. What is the average Area (in %) of Estonia per year?
Your answer should be very brief. 23.71. What is the average Area (in %) in Senegal per year?
Your answer should be compact. 45.83. What is the average Area (in %) of Slovak Republic per year?
Ensure brevity in your answer.  50.32. In the year 1994, what is the difference between the Area (in %) of Eritrea and Area (in %) of Estonia?
Give a very brief answer. 47.35. In the year 1994, what is the difference between the Area (in %) of Eritrea and Area (in %) of Senegal?
Offer a very short reply. 27.02. In the year 1994, what is the difference between the Area (in %) in Eritrea and Area (in %) in Slovak Republic?
Make the answer very short. 22.47. In the year 1994, what is the difference between the Area (in %) in Estonia and Area (in %) in Senegal?
Your response must be concise. -20.33. In the year 1994, what is the difference between the Area (in %) in Estonia and Area (in %) in Slovak Republic?
Provide a short and direct response. -24.88. In the year 1994, what is the difference between the Area (in %) in Senegal and Area (in %) in Slovak Republic?
Make the answer very short. -4.55. In the year 1995, what is the difference between the Area (in %) in Eritrea and Area (in %) in Estonia?
Provide a short and direct response. 49.96. In the year 1995, what is the difference between the Area (in %) in Eritrea and Area (in %) in Senegal?
Ensure brevity in your answer.  27.55. In the year 1995, what is the difference between the Area (in %) of Eritrea and Area (in %) of Slovak Republic?
Your response must be concise. 22.48. In the year 1995, what is the difference between the Area (in %) in Estonia and Area (in %) in Senegal?
Offer a terse response. -22.41. In the year 1995, what is the difference between the Area (in %) of Estonia and Area (in %) of Slovak Republic?
Offer a terse response. -27.47. In the year 1995, what is the difference between the Area (in %) in Senegal and Area (in %) in Slovak Republic?
Give a very brief answer. -5.07. In the year 1996, what is the difference between the Area (in %) of Eritrea and Area (in %) of Estonia?
Your answer should be compact. 48.95. In the year 1996, what is the difference between the Area (in %) in Eritrea and Area (in %) in Senegal?
Your answer should be very brief. 26.39. In the year 1996, what is the difference between the Area (in %) of Eritrea and Area (in %) of Slovak Republic?
Ensure brevity in your answer.  21.84. In the year 1996, what is the difference between the Area (in %) in Estonia and Area (in %) in Senegal?
Your answer should be compact. -22.55. In the year 1996, what is the difference between the Area (in %) in Estonia and Area (in %) in Slovak Republic?
Your answer should be very brief. -27.1. In the year 1996, what is the difference between the Area (in %) of Senegal and Area (in %) of Slovak Republic?
Keep it short and to the point. -4.55. In the year 1997, what is the difference between the Area (in %) in Eritrea and Area (in %) in Estonia?
Keep it short and to the point. 48.74. In the year 1997, what is the difference between the Area (in %) of Eritrea and Area (in %) of Senegal?
Offer a terse response. 28.06. In the year 1997, what is the difference between the Area (in %) of Eritrea and Area (in %) of Slovak Republic?
Your answer should be very brief. 22.04. In the year 1997, what is the difference between the Area (in %) in Estonia and Area (in %) in Senegal?
Keep it short and to the point. -20.68. In the year 1997, what is the difference between the Area (in %) of Estonia and Area (in %) of Slovak Republic?
Make the answer very short. -26.7. In the year 1997, what is the difference between the Area (in %) in Senegal and Area (in %) in Slovak Republic?
Provide a succinct answer. -6.02. In the year 1998, what is the difference between the Area (in %) in Eritrea and Area (in %) in Estonia?
Provide a succinct answer. 49.33. In the year 1998, what is the difference between the Area (in %) of Eritrea and Area (in %) of Senegal?
Make the answer very short. 30.35. In the year 1998, what is the difference between the Area (in %) of Eritrea and Area (in %) of Slovak Republic?
Keep it short and to the point. 23.14. In the year 1998, what is the difference between the Area (in %) of Estonia and Area (in %) of Senegal?
Give a very brief answer. -18.97. In the year 1998, what is the difference between the Area (in %) of Estonia and Area (in %) of Slovak Republic?
Your answer should be compact. -26.19. In the year 1998, what is the difference between the Area (in %) in Senegal and Area (in %) in Slovak Republic?
Provide a succinct answer. -7.21. In the year 1999, what is the difference between the Area (in %) of Eritrea and Area (in %) of Estonia?
Give a very brief answer. 50.32. In the year 1999, what is the difference between the Area (in %) in Eritrea and Area (in %) in Senegal?
Ensure brevity in your answer.  26.6. In the year 1999, what is the difference between the Area (in %) in Eritrea and Area (in %) in Slovak Republic?
Offer a very short reply. 23.14. In the year 1999, what is the difference between the Area (in %) in Estonia and Area (in %) in Senegal?
Make the answer very short. -23.71. In the year 1999, what is the difference between the Area (in %) of Estonia and Area (in %) of Slovak Republic?
Ensure brevity in your answer.  -27.18. In the year 1999, what is the difference between the Area (in %) of Senegal and Area (in %) of Slovak Republic?
Make the answer very short. -3.46. In the year 2000, what is the difference between the Area (in %) of Eritrea and Area (in %) of Estonia?
Keep it short and to the point. 51.29. In the year 2000, what is the difference between the Area (in %) in Eritrea and Area (in %) in Senegal?
Ensure brevity in your answer.  27.67. In the year 2000, what is the difference between the Area (in %) in Eritrea and Area (in %) in Slovak Republic?
Keep it short and to the point. 23.83. In the year 2000, what is the difference between the Area (in %) in Estonia and Area (in %) in Senegal?
Keep it short and to the point. -23.63. In the year 2000, what is the difference between the Area (in %) of Estonia and Area (in %) of Slovak Republic?
Ensure brevity in your answer.  -27.47. In the year 2000, what is the difference between the Area (in %) in Senegal and Area (in %) in Slovak Republic?
Offer a terse response. -3.84. In the year 2001, what is the difference between the Area (in %) in Eritrea and Area (in %) in Estonia?
Give a very brief answer. 53.58. In the year 2001, what is the difference between the Area (in %) in Eritrea and Area (in %) in Senegal?
Keep it short and to the point. 28.87. In the year 2001, what is the difference between the Area (in %) of Eritrea and Area (in %) of Slovak Republic?
Keep it short and to the point. 27.69. In the year 2001, what is the difference between the Area (in %) of Estonia and Area (in %) of Senegal?
Make the answer very short. -24.71. In the year 2001, what is the difference between the Area (in %) of Estonia and Area (in %) of Slovak Republic?
Your response must be concise. -25.89. In the year 2001, what is the difference between the Area (in %) in Senegal and Area (in %) in Slovak Republic?
Your response must be concise. -1.18. What is the ratio of the Area (in %) of Estonia in 1994 to that in 1995?
Keep it short and to the point. 1.11. What is the ratio of the Area (in %) in Senegal in 1994 to that in 1995?
Offer a terse response. 1.01. What is the ratio of the Area (in %) of Slovak Republic in 1994 to that in 1995?
Offer a very short reply. 1. What is the ratio of the Area (in %) in Eritrea in 1994 to that in 1996?
Offer a terse response. 1.01. What is the ratio of the Area (in %) in Estonia in 1994 to that in 1996?
Your answer should be compact. 1.1. What is the ratio of the Area (in %) of Senegal in 1994 to that in 1996?
Offer a terse response. 1. What is the ratio of the Area (in %) of Slovak Republic in 1994 to that in 1996?
Make the answer very short. 1. What is the ratio of the Area (in %) of Estonia in 1994 to that in 1997?
Your answer should be very brief. 1.08. What is the ratio of the Area (in %) of Slovak Republic in 1994 to that in 1997?
Make the answer very short. 1. What is the ratio of the Area (in %) in Eritrea in 1994 to that in 1998?
Ensure brevity in your answer.  0.99. What is the ratio of the Area (in %) in Estonia in 1994 to that in 1998?
Your response must be concise. 1.06. What is the ratio of the Area (in %) of Senegal in 1994 to that in 1998?
Offer a very short reply. 1.06. What is the ratio of the Area (in %) of Slovak Republic in 1994 to that in 1998?
Offer a very short reply. 1. What is the ratio of the Area (in %) of Estonia in 1994 to that in 1999?
Your response must be concise. 1.1. What is the ratio of the Area (in %) of Senegal in 1994 to that in 1999?
Provide a short and direct response. 0.98. What is the ratio of the Area (in %) of Slovak Republic in 1994 to that in 1999?
Your answer should be compact. 1. What is the ratio of the Area (in %) of Eritrea in 1994 to that in 2000?
Your answer should be very brief. 0.98. What is the ratio of the Area (in %) in Estonia in 1994 to that in 2000?
Provide a succinct answer. 1.12. What is the ratio of the Area (in %) in Senegal in 1994 to that in 2000?
Offer a terse response. 0.99. What is the ratio of the Area (in %) in Eritrea in 1994 to that in 2001?
Make the answer very short. 0.98. What is the ratio of the Area (in %) of Estonia in 1994 to that in 2001?
Your response must be concise. 1.24. What is the ratio of the Area (in %) in Senegal in 1994 to that in 2001?
Provide a succinct answer. 1.01. What is the ratio of the Area (in %) of Slovak Republic in 1994 to that in 2001?
Your answer should be very brief. 1.08. What is the ratio of the Area (in %) in Eritrea in 1995 to that in 1996?
Give a very brief answer. 1.01. What is the ratio of the Area (in %) in Estonia in 1995 to that in 1996?
Provide a succinct answer. 0.99. What is the ratio of the Area (in %) in Senegal in 1995 to that in 1996?
Provide a short and direct response. 0.99. What is the ratio of the Area (in %) in Eritrea in 1995 to that in 1997?
Keep it short and to the point. 1.01. What is the ratio of the Area (in %) in Estonia in 1995 to that in 1997?
Keep it short and to the point. 0.97. What is the ratio of the Area (in %) in Senegal in 1995 to that in 1997?
Keep it short and to the point. 1.02. What is the ratio of the Area (in %) of Slovak Republic in 1995 to that in 1997?
Your response must be concise. 1. What is the ratio of the Area (in %) of Estonia in 1995 to that in 1998?
Offer a terse response. 0.95. What is the ratio of the Area (in %) of Senegal in 1995 to that in 1998?
Offer a very short reply. 1.05. What is the ratio of the Area (in %) of Slovak Republic in 1995 to that in 1998?
Your response must be concise. 1. What is the ratio of the Area (in %) in Estonia in 1995 to that in 1999?
Ensure brevity in your answer.  0.99. What is the ratio of the Area (in %) of Senegal in 1995 to that in 1999?
Make the answer very short. 0.97. What is the ratio of the Area (in %) of Slovak Republic in 1995 to that in 1999?
Ensure brevity in your answer.  1. What is the ratio of the Area (in %) of Eritrea in 1995 to that in 2000?
Give a very brief answer. 0.98. What is the ratio of the Area (in %) in Senegal in 1995 to that in 2000?
Your answer should be very brief. 0.98. What is the ratio of the Area (in %) of Eritrea in 1995 to that in 2001?
Offer a terse response. 0.98. What is the ratio of the Area (in %) of Estonia in 1995 to that in 2001?
Give a very brief answer. 1.11. What is the ratio of the Area (in %) of Slovak Republic in 1995 to that in 2001?
Your answer should be very brief. 1.08. What is the ratio of the Area (in %) of Eritrea in 1996 to that in 1997?
Provide a short and direct response. 1. What is the ratio of the Area (in %) in Estonia in 1996 to that in 1997?
Your answer should be very brief. 0.98. What is the ratio of the Area (in %) of Senegal in 1996 to that in 1997?
Offer a very short reply. 1.03. What is the ratio of the Area (in %) of Eritrea in 1996 to that in 1998?
Provide a short and direct response. 0.98. What is the ratio of the Area (in %) in Estonia in 1996 to that in 1998?
Your response must be concise. 0.96. What is the ratio of the Area (in %) in Senegal in 1996 to that in 1998?
Give a very brief answer. 1.06. What is the ratio of the Area (in %) in Eritrea in 1996 to that in 1999?
Ensure brevity in your answer.  0.98. What is the ratio of the Area (in %) in Estonia in 1996 to that in 1999?
Your answer should be compact. 1. What is the ratio of the Area (in %) of Senegal in 1996 to that in 1999?
Provide a short and direct response. 0.98. What is the ratio of the Area (in %) in Slovak Republic in 1996 to that in 1999?
Provide a short and direct response. 1. What is the ratio of the Area (in %) of Eritrea in 1996 to that in 2000?
Your answer should be compact. 0.97. What is the ratio of the Area (in %) in Estonia in 1996 to that in 2000?
Your answer should be very brief. 1.02. What is the ratio of the Area (in %) in Senegal in 1996 to that in 2000?
Your answer should be compact. 0.99. What is the ratio of the Area (in %) in Slovak Republic in 1996 to that in 2000?
Provide a short and direct response. 1. What is the ratio of the Area (in %) of Eritrea in 1996 to that in 2001?
Keep it short and to the point. 0.97. What is the ratio of the Area (in %) of Estonia in 1996 to that in 2001?
Your answer should be compact. 1.13. What is the ratio of the Area (in %) in Senegal in 1996 to that in 2001?
Give a very brief answer. 1.01. What is the ratio of the Area (in %) in Slovak Republic in 1996 to that in 2001?
Offer a terse response. 1.08. What is the ratio of the Area (in %) of Eritrea in 1997 to that in 1998?
Your answer should be compact. 0.99. What is the ratio of the Area (in %) in Estonia in 1997 to that in 1998?
Offer a terse response. 0.98. What is the ratio of the Area (in %) of Senegal in 1997 to that in 1998?
Your answer should be compact. 1.03. What is the ratio of the Area (in %) of Slovak Republic in 1997 to that in 1998?
Make the answer very short. 1. What is the ratio of the Area (in %) in Eritrea in 1997 to that in 1999?
Provide a succinct answer. 0.99. What is the ratio of the Area (in %) in Senegal in 1997 to that in 1999?
Your answer should be compact. 0.95. What is the ratio of the Area (in %) of Slovak Republic in 1997 to that in 1999?
Provide a succinct answer. 1. What is the ratio of the Area (in %) in Eritrea in 1997 to that in 2000?
Your answer should be very brief. 0.98. What is the ratio of the Area (in %) in Estonia in 1997 to that in 2000?
Offer a terse response. 1.04. What is the ratio of the Area (in %) of Senegal in 1997 to that in 2000?
Ensure brevity in your answer.  0.96. What is the ratio of the Area (in %) of Slovak Republic in 1997 to that in 2000?
Offer a very short reply. 1. What is the ratio of the Area (in %) of Eritrea in 1997 to that in 2001?
Provide a succinct answer. 0.98. What is the ratio of the Area (in %) of Estonia in 1997 to that in 2001?
Offer a terse response. 1.15. What is the ratio of the Area (in %) in Senegal in 1997 to that in 2001?
Give a very brief answer. 0.98. What is the ratio of the Area (in %) of Slovak Republic in 1997 to that in 2001?
Ensure brevity in your answer.  1.08. What is the ratio of the Area (in %) in Eritrea in 1998 to that in 1999?
Offer a very short reply. 1. What is the ratio of the Area (in %) in Estonia in 1998 to that in 1999?
Offer a very short reply. 1.04. What is the ratio of the Area (in %) in Senegal in 1998 to that in 1999?
Offer a very short reply. 0.92. What is the ratio of the Area (in %) of Slovak Republic in 1998 to that in 1999?
Provide a succinct answer. 1. What is the ratio of the Area (in %) in Eritrea in 1998 to that in 2000?
Your answer should be compact. 0.99. What is the ratio of the Area (in %) of Estonia in 1998 to that in 2000?
Your answer should be very brief. 1.06. What is the ratio of the Area (in %) of Senegal in 1998 to that in 2000?
Keep it short and to the point. 0.93. What is the ratio of the Area (in %) in Estonia in 1998 to that in 2001?
Keep it short and to the point. 1.17. What is the ratio of the Area (in %) of Senegal in 1998 to that in 2001?
Provide a short and direct response. 0.95. What is the ratio of the Area (in %) in Slovak Republic in 1998 to that in 2001?
Keep it short and to the point. 1.08. What is the ratio of the Area (in %) of Estonia in 1999 to that in 2000?
Offer a terse response. 1.02. What is the ratio of the Area (in %) of Senegal in 1999 to that in 2000?
Offer a terse response. 1.01. What is the ratio of the Area (in %) of Estonia in 1999 to that in 2001?
Give a very brief answer. 1.12. What is the ratio of the Area (in %) of Senegal in 1999 to that in 2001?
Your answer should be compact. 1.04. What is the ratio of the Area (in %) of Slovak Republic in 1999 to that in 2001?
Provide a short and direct response. 1.08. What is the ratio of the Area (in %) of Estonia in 2000 to that in 2001?
Offer a very short reply. 1.11. What is the ratio of the Area (in %) of Senegal in 2000 to that in 2001?
Your answer should be compact. 1.03. What is the ratio of the Area (in %) in Slovak Republic in 2000 to that in 2001?
Make the answer very short. 1.08. What is the difference between the highest and the second highest Area (in %) of Eritrea?
Provide a short and direct response. 0.02. What is the difference between the highest and the second highest Area (in %) in Estonia?
Your answer should be compact. 1.37. What is the difference between the highest and the second highest Area (in %) in Senegal?
Your answer should be very brief. 0.44. What is the difference between the highest and the second highest Area (in %) of Slovak Republic?
Make the answer very short. 0. What is the difference between the highest and the lowest Area (in %) of Eritrea?
Give a very brief answer. 1.92. What is the difference between the highest and the lowest Area (in %) in Estonia?
Ensure brevity in your answer.  4.98. What is the difference between the highest and the lowest Area (in %) in Senegal?
Offer a very short reply. 3.75. What is the difference between the highest and the lowest Area (in %) of Slovak Republic?
Keep it short and to the point. 3.97. 